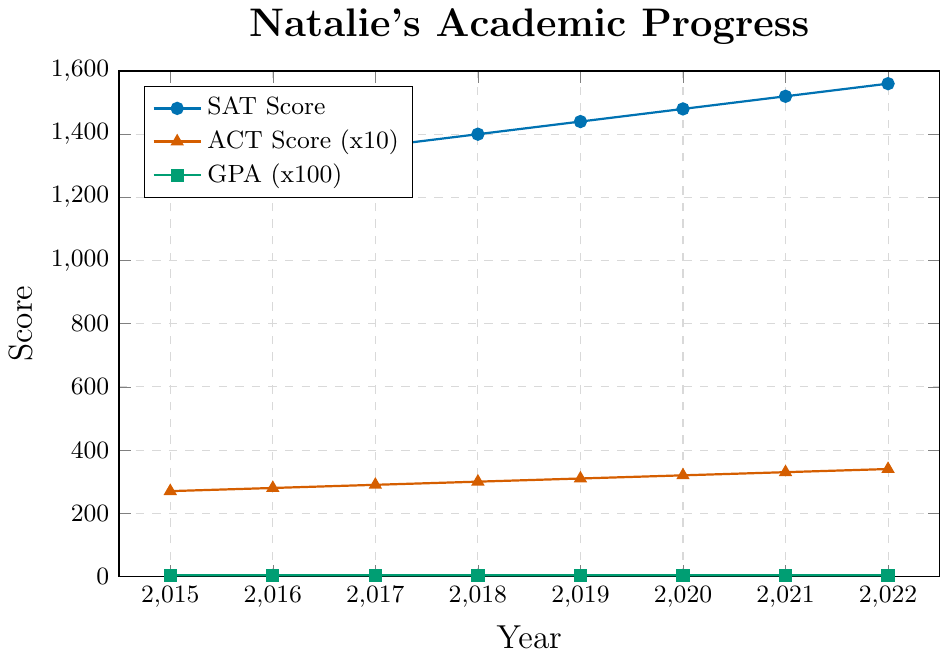What's the trend of Natalie's GPA from 2015 to 2022? Begin by observing the green line representing the GPA over the years. Notice that it starts at 3.7 in 2015, increases to 3.8 in 2016, 3.9 in 2017, and then reaches 4.0 from 2018 onwards, where it remains constant through 2022.
Answer: Increasing initially, then constant In which year did Natalie's SAT score first hit 1500? Look at the blue line representing SAT scores and find the point at which it first reaches or surpasses 1500. The blue line intersects the 1500 mark in the year 2021.
Answer: 2021 How much did Natalie's ACT score increase from 2015 to 2022? The red line shows the ACT scores over time. From 2015 to 2022, the ACT score rises from 27 to 34. Calculate the difference: 34 - 27.
Answer: 7 Between 2018 and 2020, what was the change in Natalie's SAT score? Locate the SAT scores for 2018 and 2020 on the blue line. The score in 2018 is 1400 and in 2020 it is 1480. Calculate the difference: 1480 - 1400.
Answer: 80 Compare the SAT and ACT scores in 2017. Which one increased more by 2021? Locate the 2017 and 2021 scores for both SAT and ACT. SAT scores: 1360 in 2017 and 1520 in 2021, with an increase of 160. ACT scores: 29 in 2017 and 33 in 2021, with an increase of 4.
Answer: SAT increased more What year did Natalie's GPA first reach 4.0? By observing the green line, you can see that the GPA reaches 4.0 in the year 2018.
Answer: 2018 Was there any year when Natalie's SAT score and ACT score increased by the same amount? To find this, compare the year-over-year increases for SAT and ACT scores. Both scores increase by 40 SAT points (1520 to 1560) and 1 ACT point (33 to 34) from 2021 to 2022.
Answer: 2021 to 2022 How consistent was Natalie's GPA from 2018 onwards? Observe the green line after 2018. The GPA remains constant at 4.0 from 2018 onwards through 2022.
Answer: Very consistent What was the total increase in Natalie's SAT score from 2015 to 2022? Find the SAT scores for 2015 and 2022: 1280 and 1560 respectively. Calculate the difference: 1560 - 1280.
Answer: 280 During which years did Natalie's ACT score improve the most rapidly? Check the steepest increase in the red line. The score increased consistently by 1 each year, but the absolute change is the same, thus all years from 2018 to 2022 have steady increases. No rapid increase is visually observable as all increments are equal.
Answer: Consistent each year 